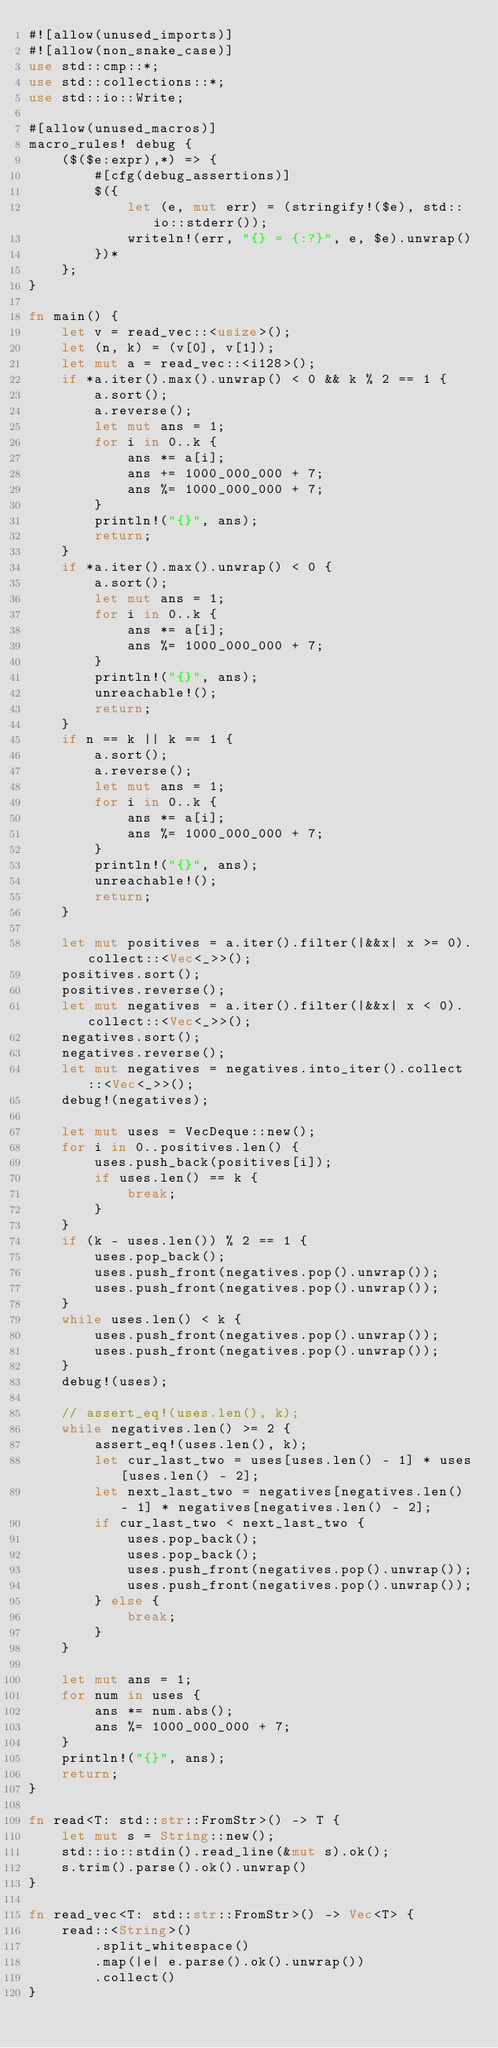Convert code to text. <code><loc_0><loc_0><loc_500><loc_500><_Rust_>#![allow(unused_imports)]
#![allow(non_snake_case)]
use std::cmp::*;
use std::collections::*;
use std::io::Write;

#[allow(unused_macros)]
macro_rules! debug {
    ($($e:expr),*) => {
        #[cfg(debug_assertions)]
        $({
            let (e, mut err) = (stringify!($e), std::io::stderr());
            writeln!(err, "{} = {:?}", e, $e).unwrap()
        })*
    };
}

fn main() {
    let v = read_vec::<usize>();
    let (n, k) = (v[0], v[1]);
    let mut a = read_vec::<i128>();
    if *a.iter().max().unwrap() < 0 && k % 2 == 1 {
        a.sort();
        a.reverse();
        let mut ans = 1;
        for i in 0..k {
            ans *= a[i];
            ans += 1000_000_000 + 7;
            ans %= 1000_000_000 + 7;
        }
        println!("{}", ans);
        return;
    }
    if *a.iter().max().unwrap() < 0 {
        a.sort();
        let mut ans = 1;
        for i in 0..k {
            ans *= a[i];
            ans %= 1000_000_000 + 7;
        }
        println!("{}", ans);
        unreachable!();
        return;
    }
    if n == k || k == 1 {
        a.sort();
        a.reverse();
        let mut ans = 1;
        for i in 0..k {
            ans *= a[i];
            ans %= 1000_000_000 + 7;
        }
        println!("{}", ans);
        unreachable!();
        return;
    }

    let mut positives = a.iter().filter(|&&x| x >= 0).collect::<Vec<_>>();
    positives.sort();
    positives.reverse();
    let mut negatives = a.iter().filter(|&&x| x < 0).collect::<Vec<_>>();
    negatives.sort();
    negatives.reverse();
    let mut negatives = negatives.into_iter().collect::<Vec<_>>();
    debug!(negatives);

    let mut uses = VecDeque::new();
    for i in 0..positives.len() {
        uses.push_back(positives[i]);
        if uses.len() == k {
            break;
        }
    }
    if (k - uses.len()) % 2 == 1 {
        uses.pop_back();
        uses.push_front(negatives.pop().unwrap());
        uses.push_front(negatives.pop().unwrap());
    }
    while uses.len() < k {
        uses.push_front(negatives.pop().unwrap());
        uses.push_front(negatives.pop().unwrap());
    }
    debug!(uses);

    // assert_eq!(uses.len(), k);
    while negatives.len() >= 2 {
        assert_eq!(uses.len(), k);
        let cur_last_two = uses[uses.len() - 1] * uses[uses.len() - 2];
        let next_last_two = negatives[negatives.len() - 1] * negatives[negatives.len() - 2];
        if cur_last_two < next_last_two {
            uses.pop_back();
            uses.pop_back();
            uses.push_front(negatives.pop().unwrap());
            uses.push_front(negatives.pop().unwrap());
        } else {
            break;
        }
    }

    let mut ans = 1;
    for num in uses {
        ans *= num.abs();
        ans %= 1000_000_000 + 7;
    }
    println!("{}", ans);
    return;
}

fn read<T: std::str::FromStr>() -> T {
    let mut s = String::new();
    std::io::stdin().read_line(&mut s).ok();
    s.trim().parse().ok().unwrap()
}

fn read_vec<T: std::str::FromStr>() -> Vec<T> {
    read::<String>()
        .split_whitespace()
        .map(|e| e.parse().ok().unwrap())
        .collect()
}
</code> 